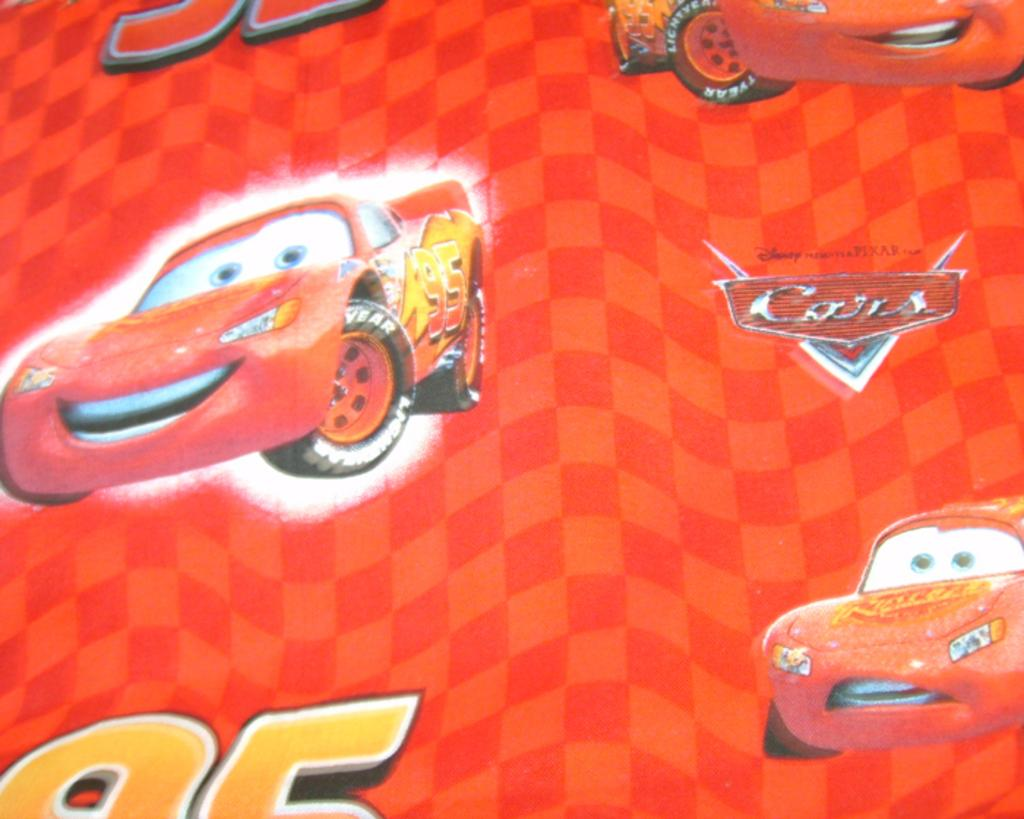What is present in the image that contains both text and images? There is a poster in the image that contains text and images. Can you describe the content of the poster? The poster contains text and images, but the specific content cannot be determined from the provided facts. What type of glove is being advised in the poster? There is no glove mentioned or depicted in the poster, so it cannot be advised or discussed in the image. 